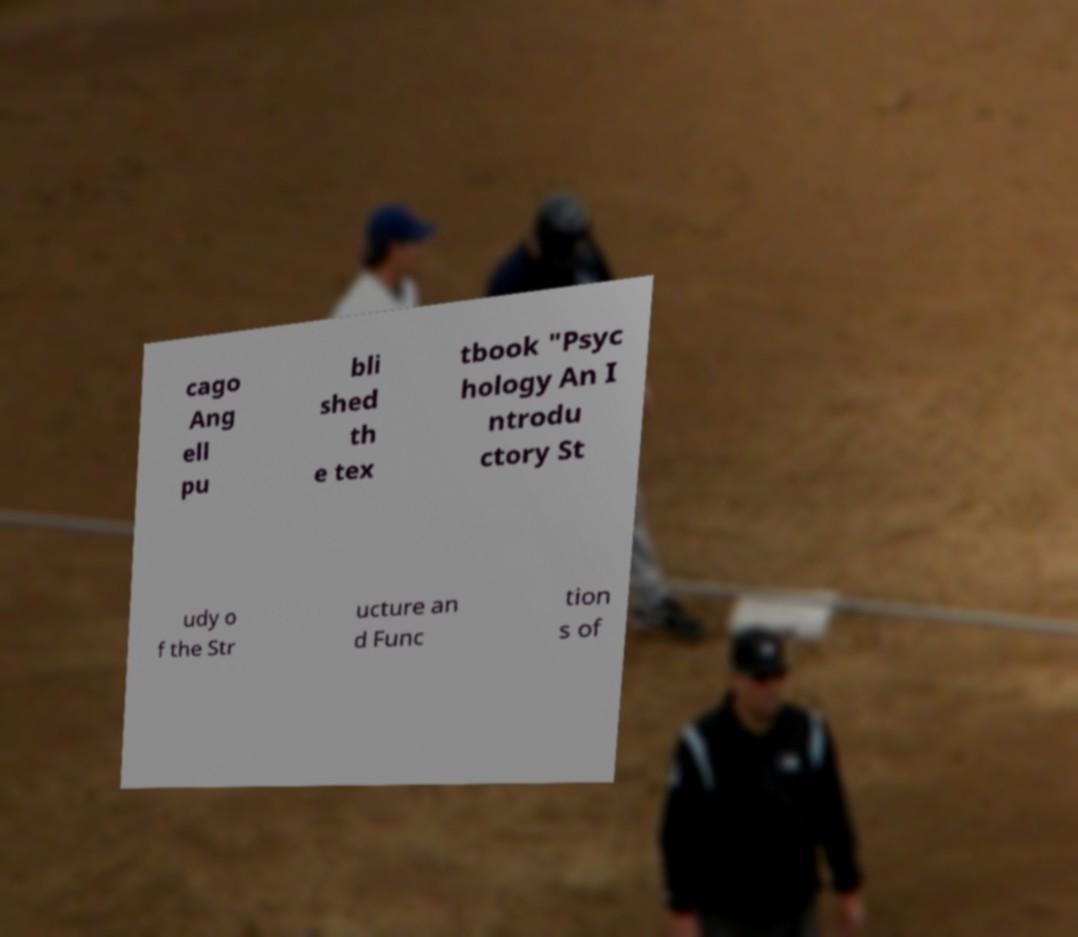Can you accurately transcribe the text from the provided image for me? cago Ang ell pu bli shed th e tex tbook "Psyc hology An I ntrodu ctory St udy o f the Str ucture an d Func tion s of 